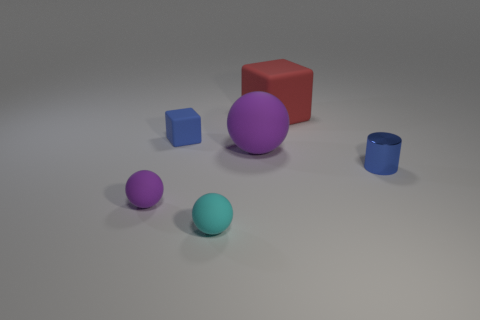Are there any other things that are the same material as the cylinder?
Offer a very short reply. No. Is the number of blue matte blocks that are behind the red rubber block less than the number of tiny rubber blocks to the left of the cyan matte thing?
Give a very brief answer. Yes. What color is the big cube?
Provide a short and direct response. Red. Are there any small cylinders that have the same color as the shiny thing?
Your answer should be compact. No. What shape is the big thing in front of the big matte thing that is on the right side of the purple thing that is behind the cylinder?
Provide a succinct answer. Sphere. What is the tiny blue thing on the right side of the red matte thing made of?
Ensure brevity in your answer.  Metal. What is the size of the matte block that is behind the small blue object that is left of the ball behind the blue shiny cylinder?
Your answer should be very brief. Large. There is a cylinder; is it the same size as the purple rubber ball on the right side of the tiny cyan rubber object?
Provide a short and direct response. No. What color is the large rubber object right of the large rubber sphere?
Give a very brief answer. Red. What is the shape of the thing that is the same color as the tiny block?
Your answer should be compact. Cylinder. 